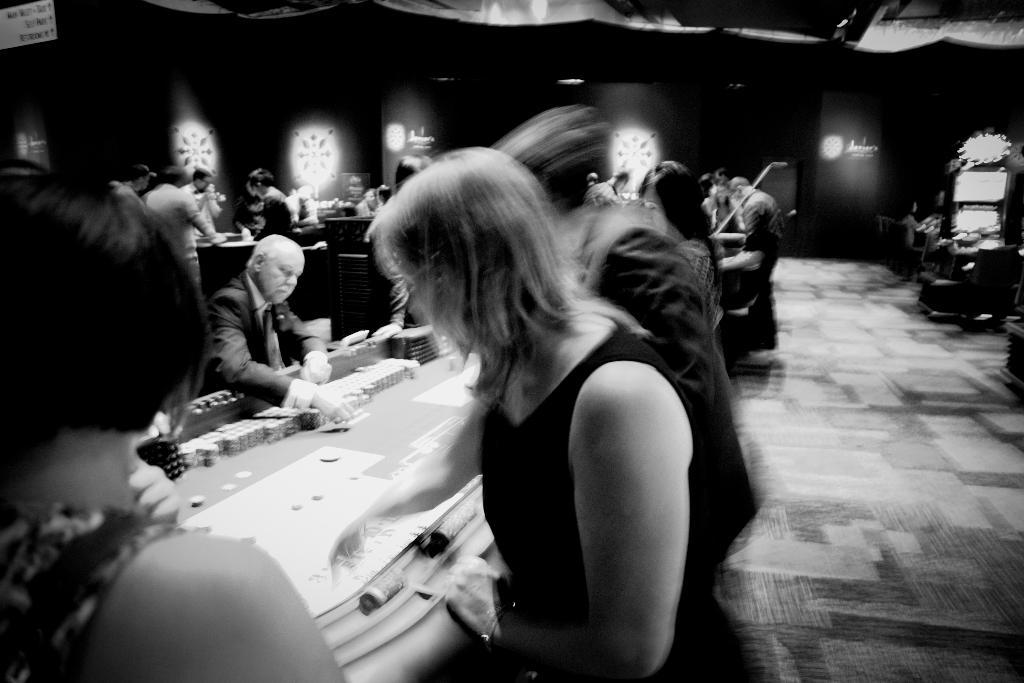What is the color scheme of the image? The image is black and white. What can be seen in the image? There are people in the image. What activity are the people engaged in? The people are playing in a casino. Can you tell me how many mice are running around on the sign in the image? There are no mice or signs present in the image. What type of jewel can be seen on the people's clothing in the image? There is no jewel visible on the people's clothing in the image. 